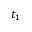Convert formula to latex. <formula><loc_0><loc_0><loc_500><loc_500>t _ { 1 }</formula> 